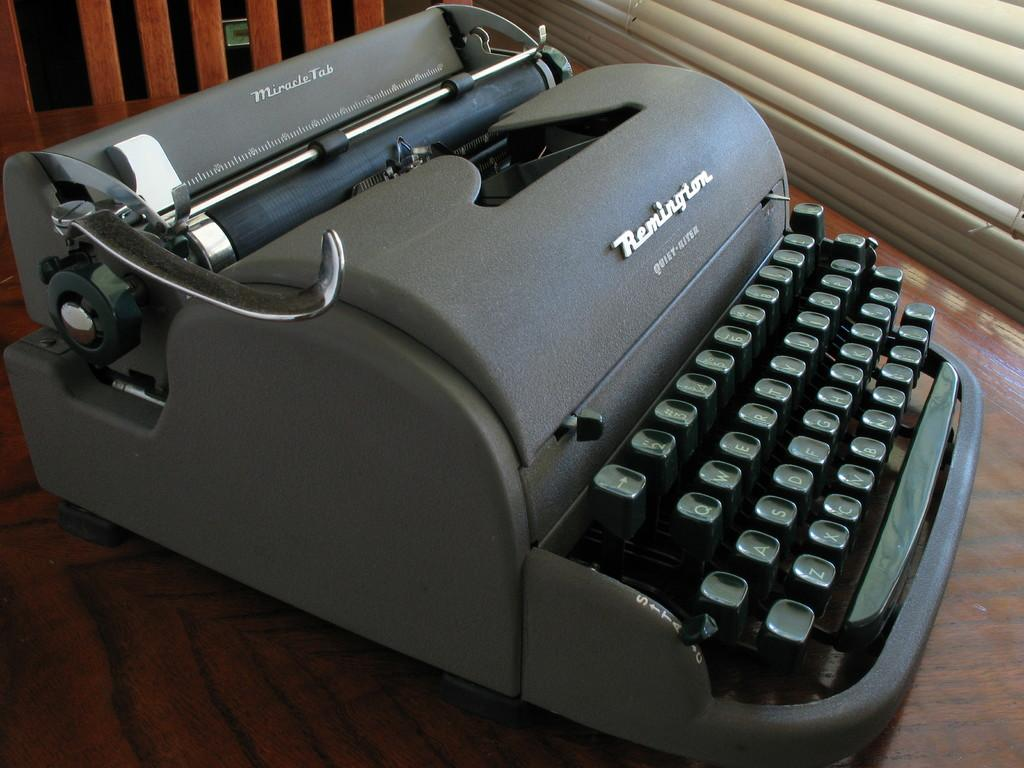<image>
Relay a brief, clear account of the picture shown. A gray typewriter form the brand Remington with the model Quiey-River 